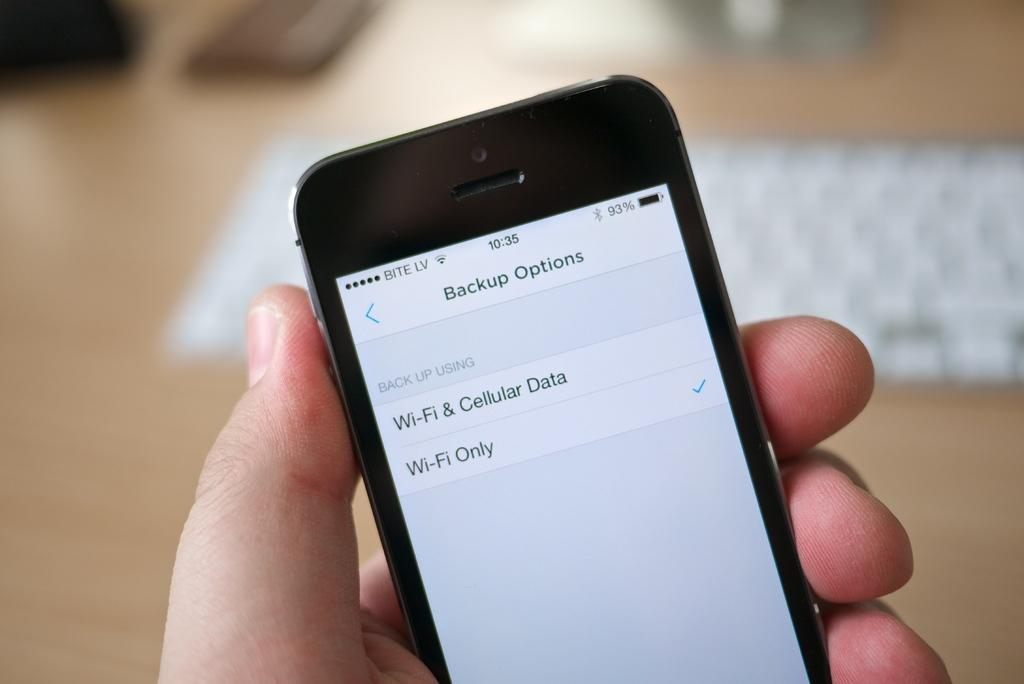<image>
Share a concise interpretation of the image provided. A cell phone shows two options for backups. 